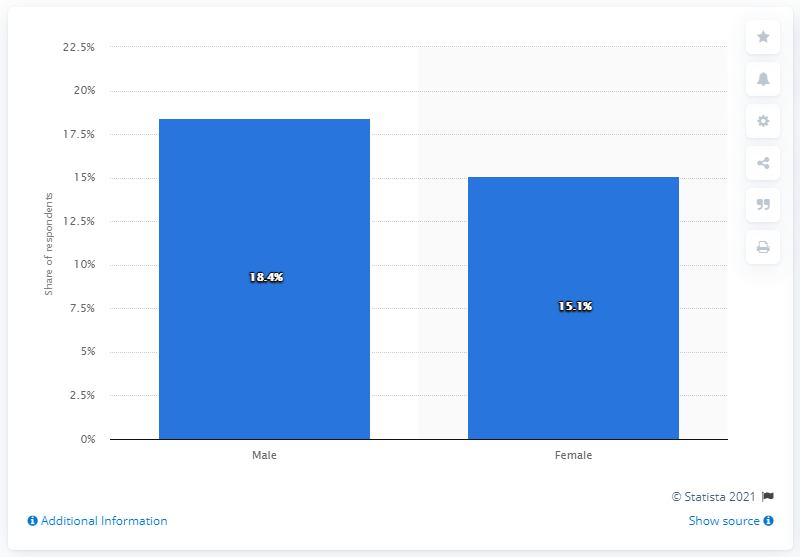Identify some key points in this picture. In the past three months, 15.1% of female respondents reported having used marijuana or cannabis. 